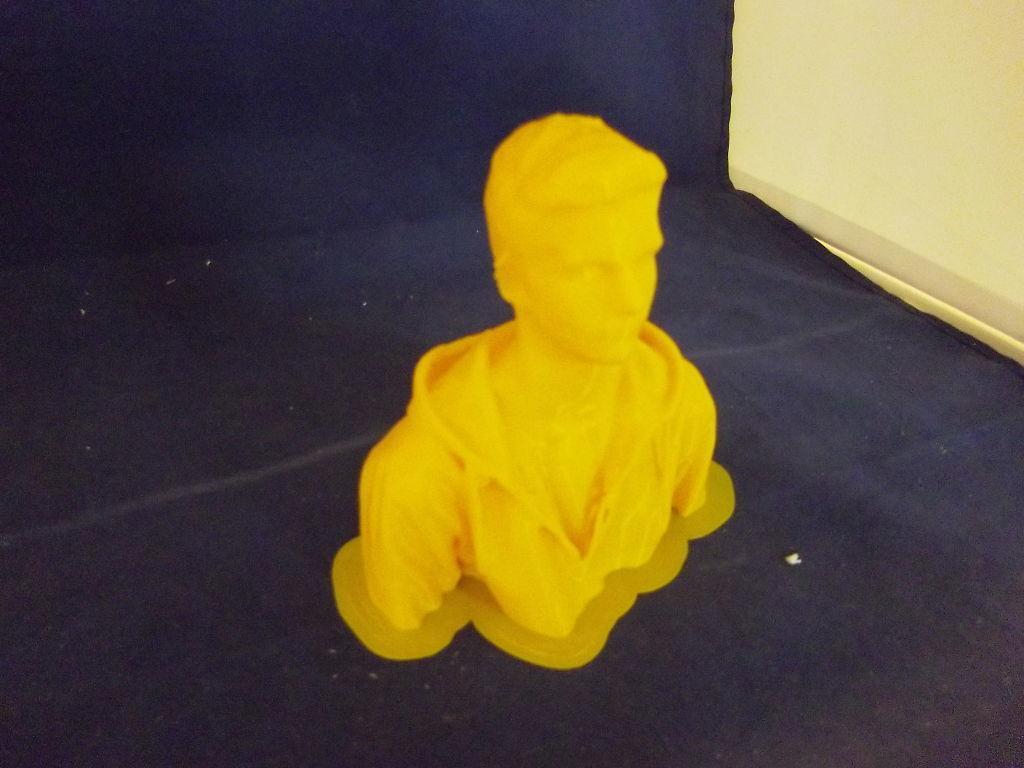Please provide a concise description of this image. In the center of the image we can see a statue which is placed on the surface. On the right side we can see a wall. 